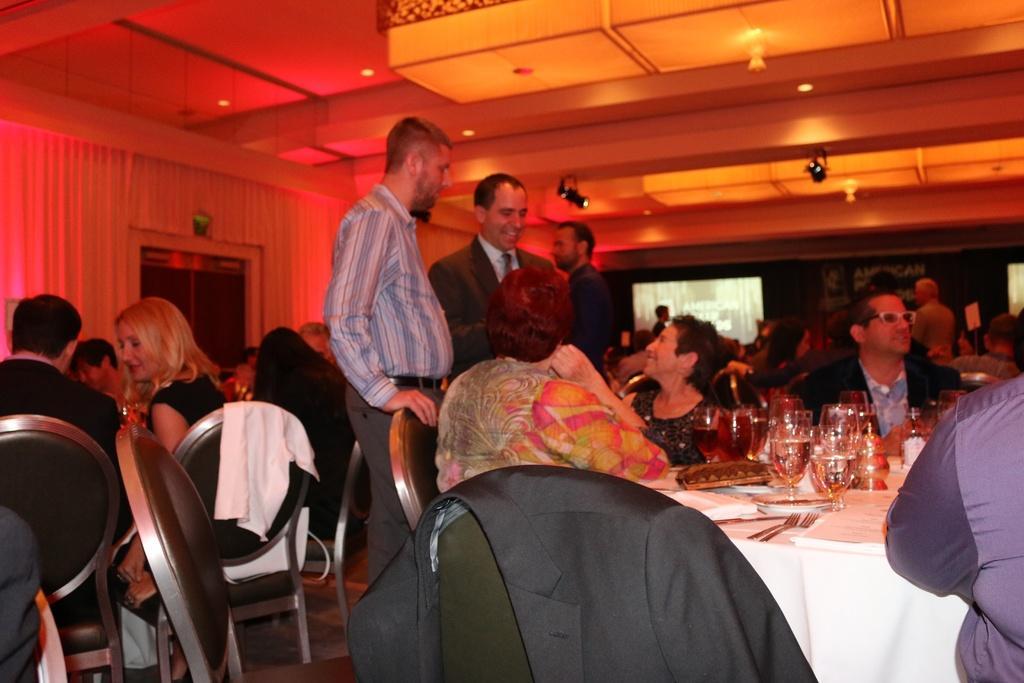In one or two sentences, can you explain what this image depicts? In this image I can see there are group of people who are sitting on a chair in front of a table and some are standing on the floor. On the table we have a couple of glasses and other of the objects on it. 